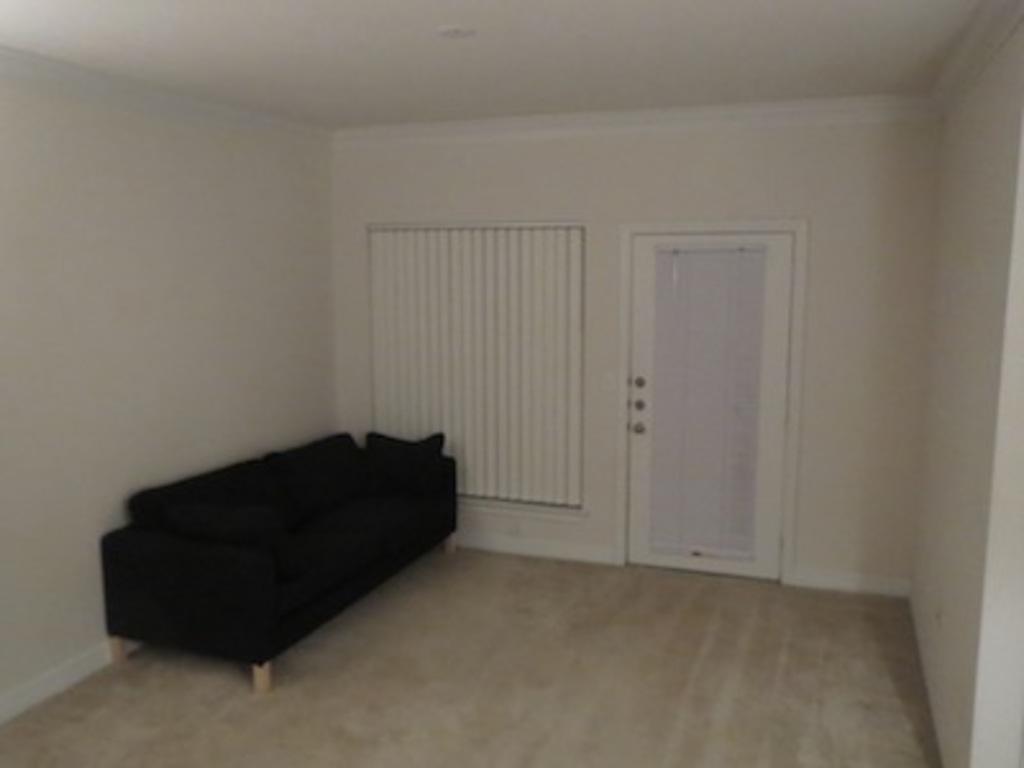Please provide a concise description of this image. A sofa is at a corner in a room. The color of the sofa is black. There is a door and a window. 